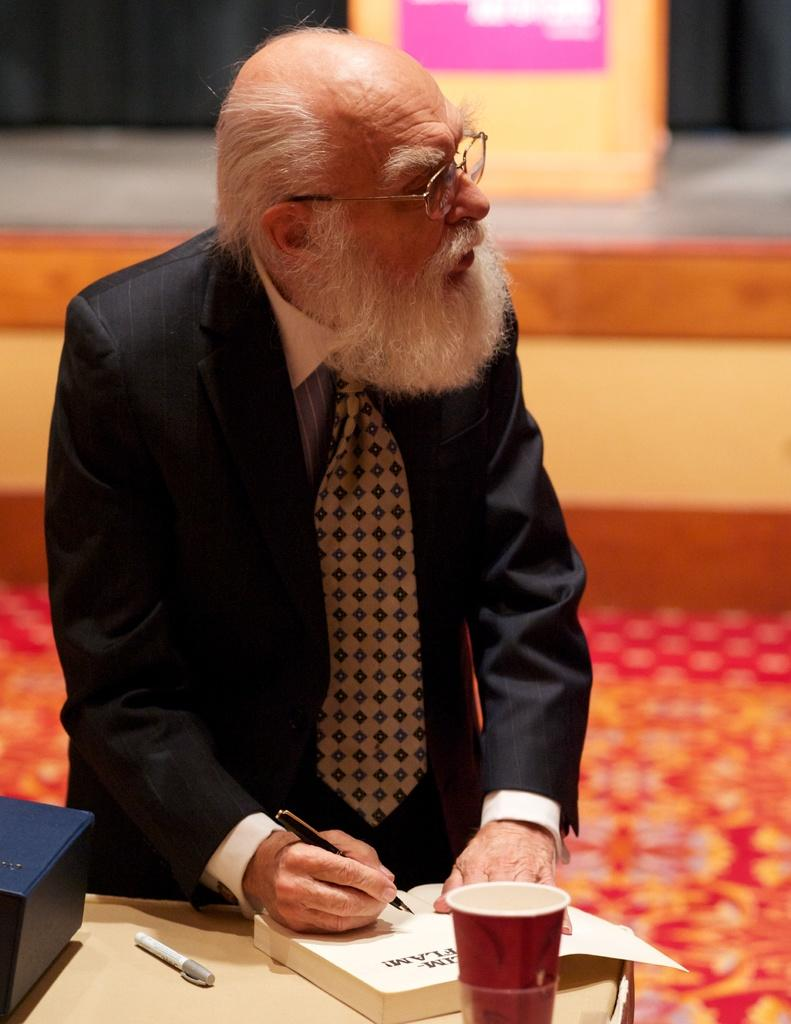What is the person in the image wearing? The person is wearing a black suit. What is the person holding in his hand? The person is holding a pen in his hand. What can be seen on the table in front of the person? There is a book, a pen, and a glass on the table in front of the person. What time of day is it in the image, and where is the flock of birds? The time of day is not mentioned in the image, and there is no flock of birds present. 